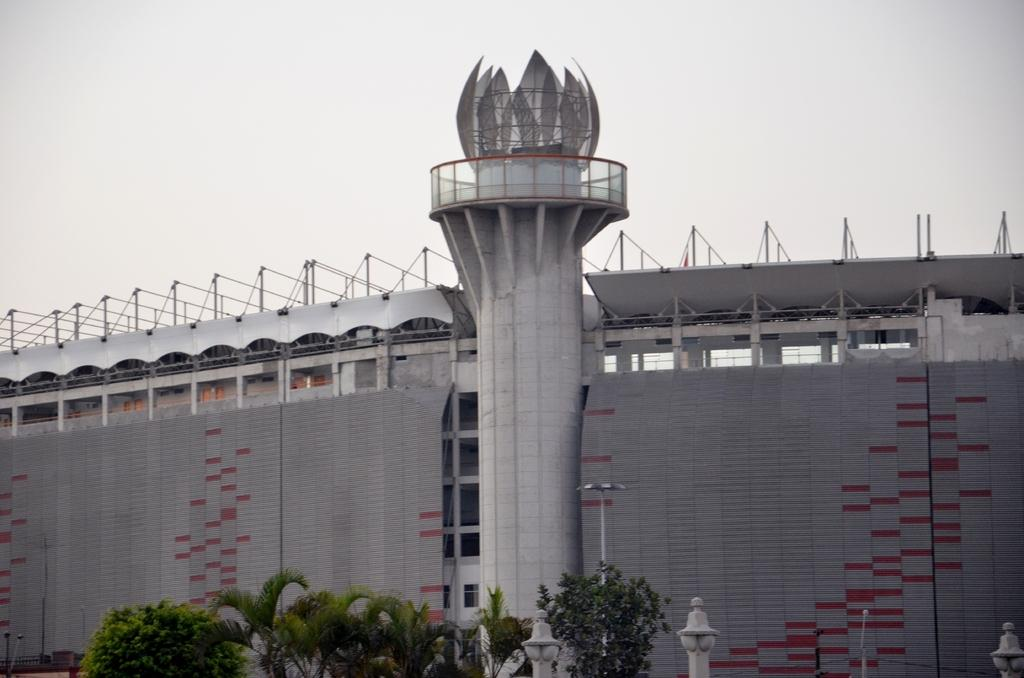What type of view is shown in the image? The image is an outside view. What can be seen at the bottom of the image? There are trees and poles at the bottom of the image. What is located in the middle of the image? There is a tower and a building in the middle of the image. What is visible at the top of the image? The sky is visible at the top of the image. Can you see a goat climbing the tower in the image? There is no goat present in the image, and therefore no such activity can be observed. What type of zipper is featured on the building in the image? There is no zipper present on the building in the image. 